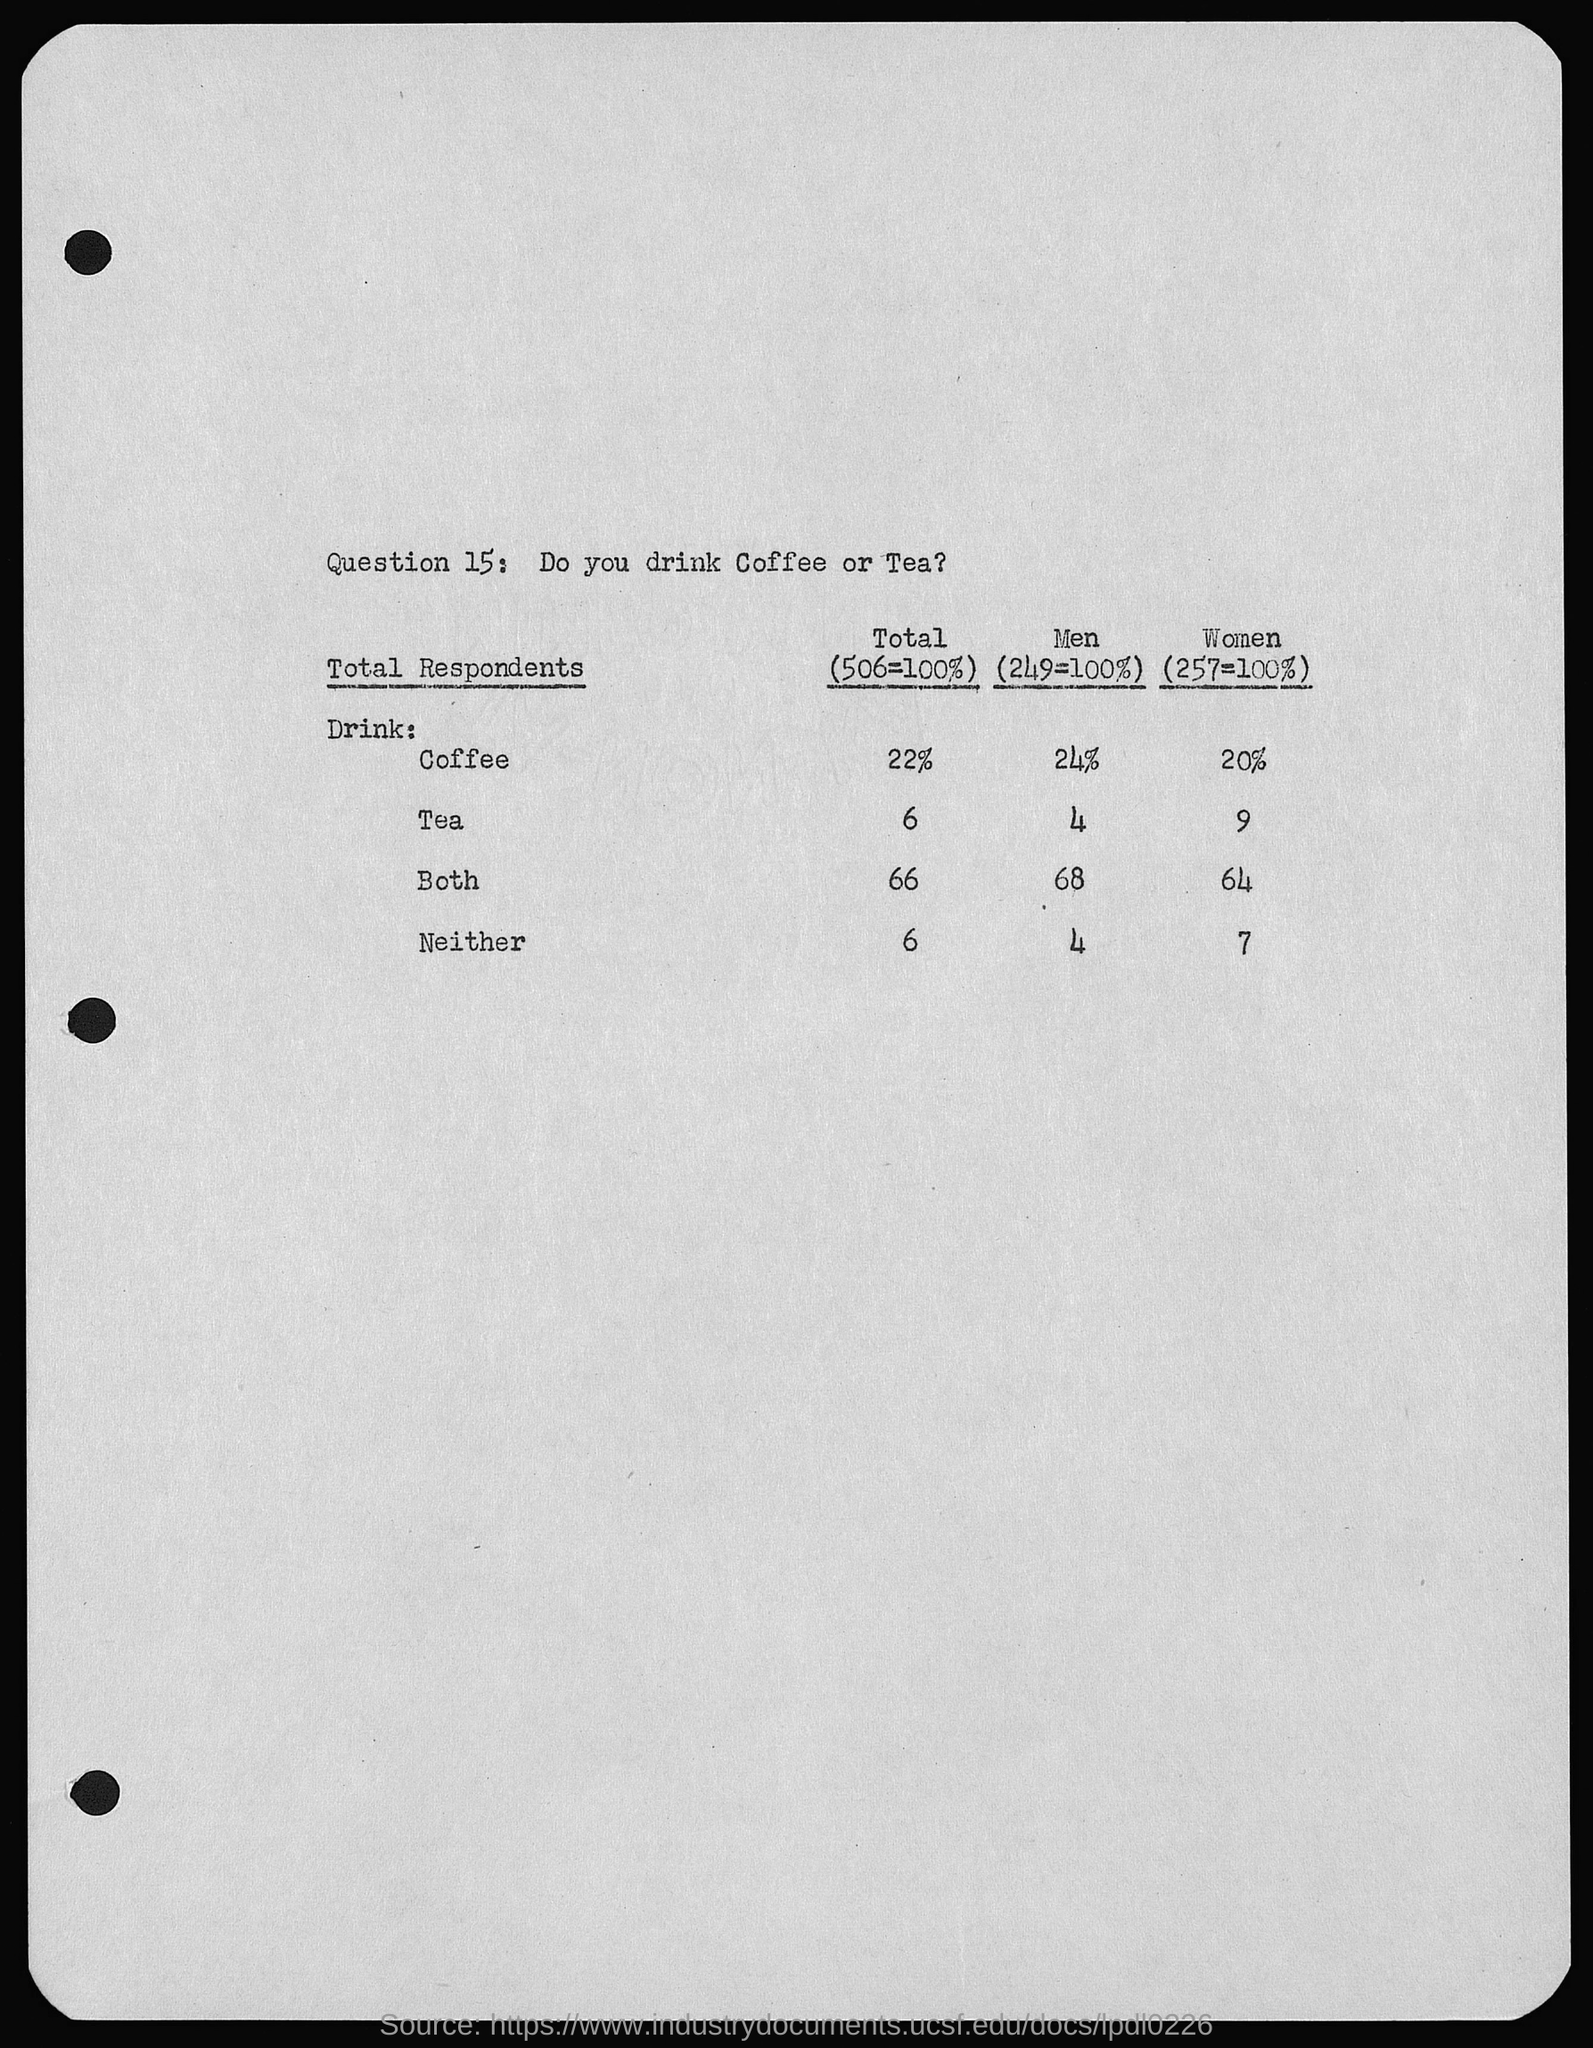What is question 15: ?
Your answer should be very brief. Do you drink Coffee or Tea?. 